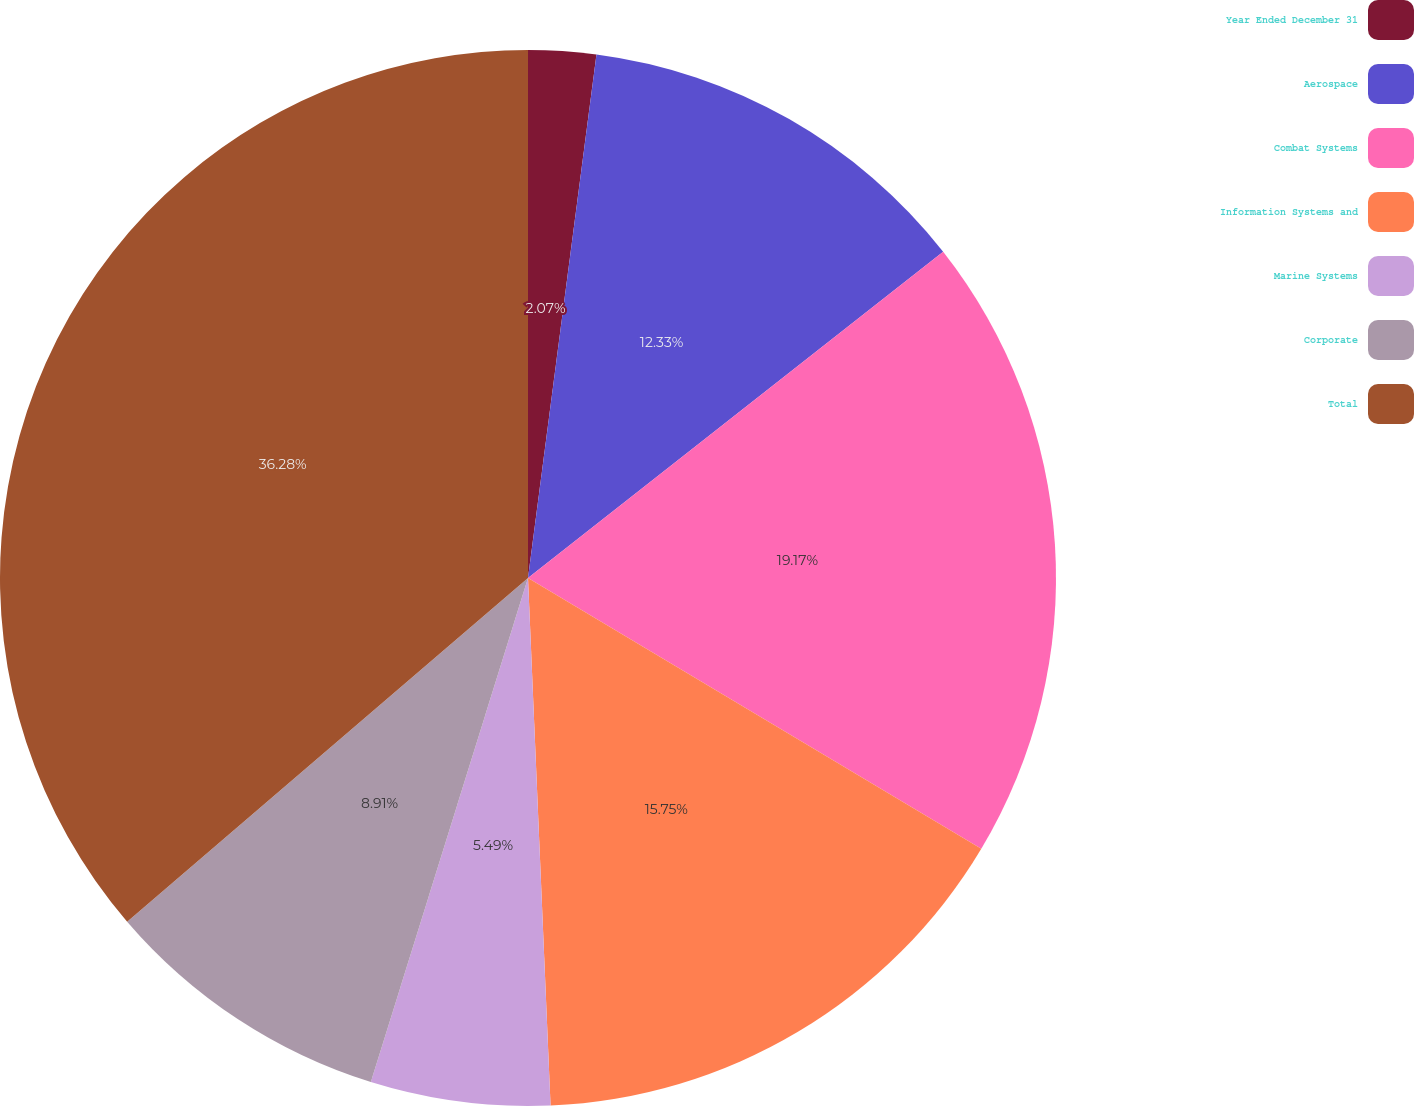<chart> <loc_0><loc_0><loc_500><loc_500><pie_chart><fcel>Year Ended December 31<fcel>Aerospace<fcel>Combat Systems<fcel>Information Systems and<fcel>Marine Systems<fcel>Corporate<fcel>Total<nl><fcel>2.07%<fcel>12.33%<fcel>19.17%<fcel>15.75%<fcel>5.49%<fcel>8.91%<fcel>36.28%<nl></chart> 